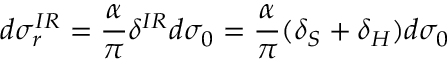<formula> <loc_0><loc_0><loc_500><loc_500>d \sigma _ { r } ^ { I R } = \frac { \alpha } { \pi } \delta ^ { I R } d \sigma _ { 0 } = \frac { \alpha } { \pi } ( \delta _ { S } + \delta _ { H } ) d \sigma _ { 0 }</formula> 